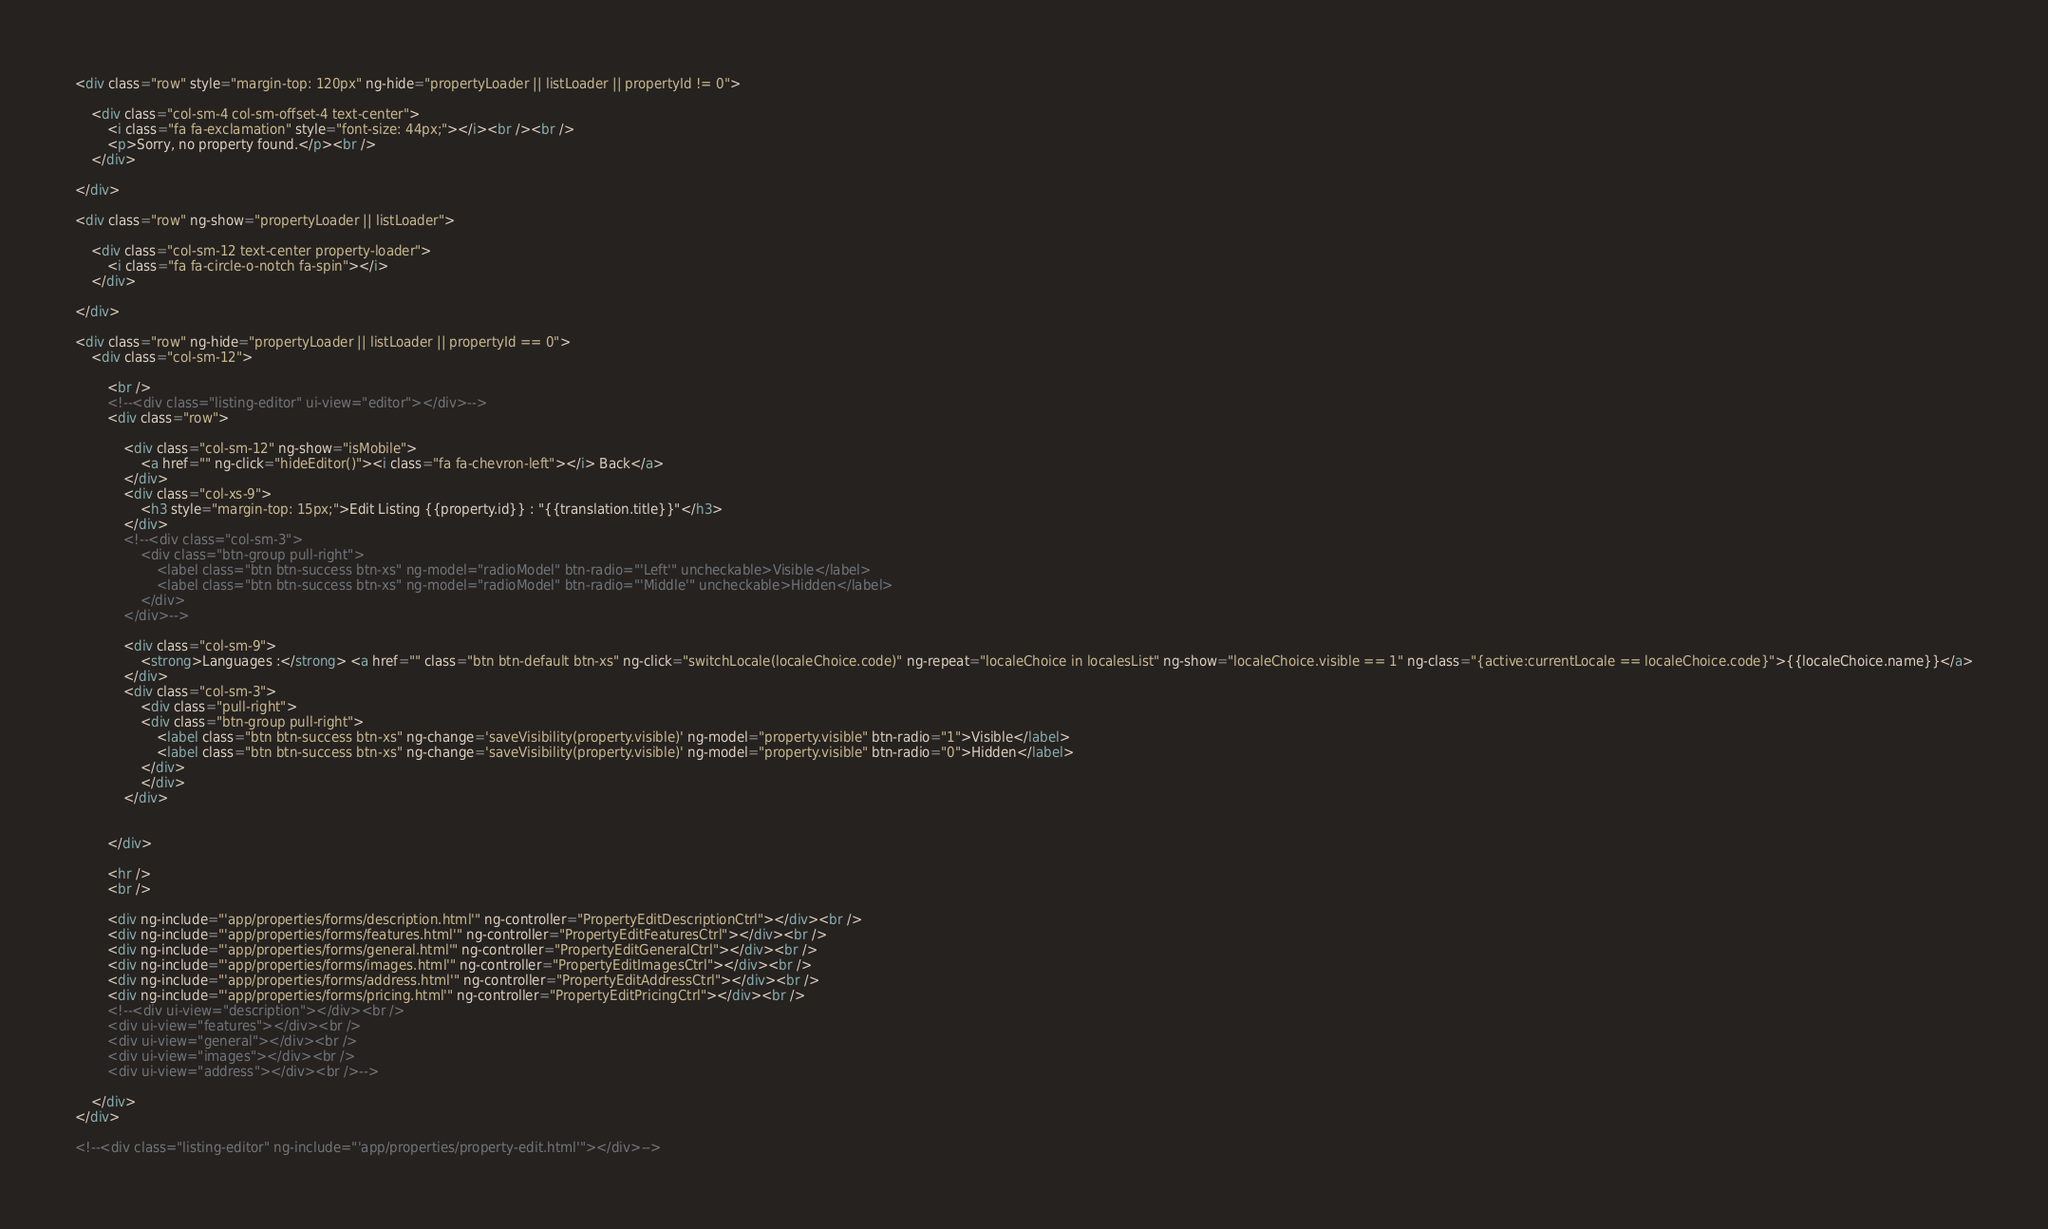Convert code to text. <code><loc_0><loc_0><loc_500><loc_500><_HTML_><div class="row" style="margin-top: 120px" ng-hide="propertyLoader || listLoader || propertyId != 0">

    <div class="col-sm-4 col-sm-offset-4 text-center">
        <i class="fa fa-exclamation" style="font-size: 44px;"></i><br /><br />
		<p>Sorry, no property found.</p><br />
    </div>  

</div>

<div class="row" ng-show="propertyLoader || listLoader">

    <div class="col-sm-12 text-center property-loader">
        <i class="fa fa-circle-o-notch fa-spin"></i>
    </div>  

</div>

<div class="row" ng-hide="propertyLoader || listLoader || propertyId == 0">
    <div class="col-sm-12">

        <br />
        <!--<div class="listing-editor" ui-view="editor"></div>-->
        <div class="row">
            
            <div class="col-sm-12" ng-show="isMobile">
                <a href="" ng-click="hideEditor()"><i class="fa fa-chevron-left"></i> Back</a>
            </div>  
            <div class="col-xs-9">
                <h3 style="margin-top: 15px;">Edit Listing {{property.id}} : "{{translation.title}}"</h3>
            </div>  
            <!--<div class="col-sm-3">
                <div class="btn-group pull-right">
                    <label class="btn btn-success btn-xs" ng-model="radioModel" btn-radio="'Left'" uncheckable>Visible</label>
                    <label class="btn btn-success btn-xs" ng-model="radioModel" btn-radio="'Middle'" uncheckable>Hidden</label>
                </div>
            </div>-->

            <div class="col-sm-9">
                <strong>Languages :</strong> <a href="" class="btn btn-default btn-xs" ng-click="switchLocale(localeChoice.code)" ng-repeat="localeChoice in localesList" ng-show="localeChoice.visible == 1" ng-class="{active:currentLocale == localeChoice.code}">{{localeChoice.name}}</a>
            </div>  
            <div class="col-sm-3">
                <div class="pull-right">
                <div class="btn-group pull-right">
                    <label class="btn btn-success btn-xs" ng-change='saveVisibility(property.visible)' ng-model="property.visible" btn-radio="1">Visible</label>
                    <label class="btn btn-success btn-xs" ng-change='saveVisibility(property.visible)' ng-model="property.visible" btn-radio="0">Hidden</label>
                </div>
                </div>
            </div>


        </div>

        <hr />
        <br />

        <div ng-include="'app/properties/forms/description.html'" ng-controller="PropertyEditDescriptionCtrl"></div><br />
        <div ng-include="'app/properties/forms/features.html'" ng-controller="PropertyEditFeaturesCtrl"></div><br />
        <div ng-include="'app/properties/forms/general.html'" ng-controller="PropertyEditGeneralCtrl"></div><br />
        <div ng-include="'app/properties/forms/images.html'" ng-controller="PropertyEditImagesCtrl"></div><br />
        <div ng-include="'app/properties/forms/address.html'" ng-controller="PropertyEditAddressCtrl"></div><br />
        <div ng-include="'app/properties/forms/pricing.html'" ng-controller="PropertyEditPricingCtrl"></div><br />
        <!--<div ui-view="description"></div><br />
        <div ui-view="features"></div><br />
        <div ui-view="general"></div><br />
        <div ui-view="images"></div><br />
        <div ui-view="address"></div><br />-->
    
    </div>
</div>

<!--<div class="listing-editor" ng-include="'app/properties/property-edit.html'"></div>-->
</code> 